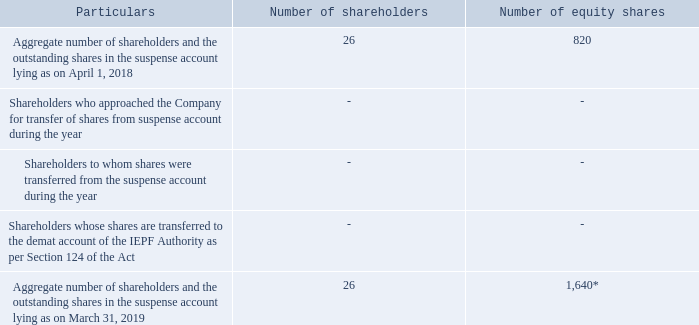Xvi. equity shares in the suspense account:
in accordance with the requirement of regulation 34(3) and part f of schedule v to the sebi listing regulations, details of equity shares in the suspense account are as follows:
*pursuant to allotment of 1:1 bonus equity shares.
the voting rights on the shares outstanding in the suspense account as on march 31, 2019 shall remain frozen till the rightful owner of such shares claims the shares.
what does the table show? Details of equity shares in the suspense account. How many shareholders approached the Company for transfer of shares from suspense account during the year? 0. How many shareholders have outstanding shares in the suspense account? 26. How many bonus equity shares were alloted during the year? 820*1 
Answer: 820. How many equity shares are there to one shareholder as on April 1, 2018? 820/26 
Answer: 31.54. How many equity shares are there to one shareholder as on March 31, 2019? 1,640/26 
Answer: 63.08. 